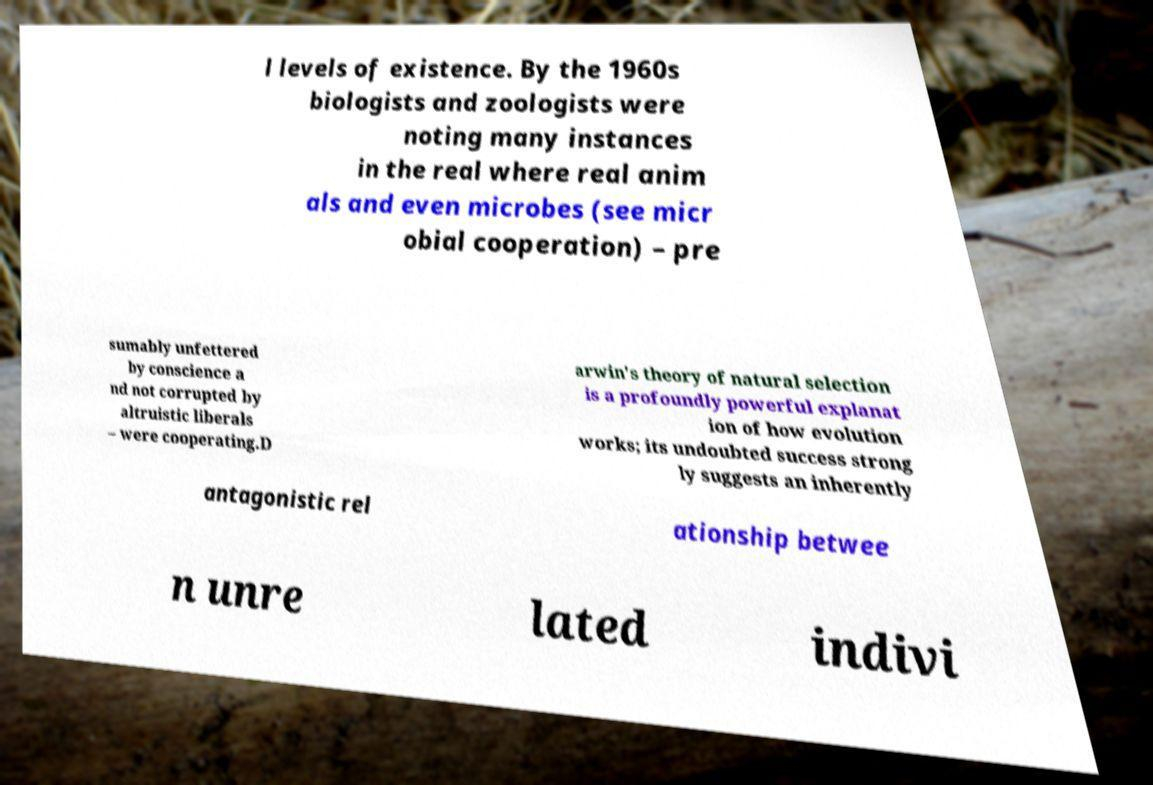There's text embedded in this image that I need extracted. Can you transcribe it verbatim? l levels of existence. By the 1960s biologists and zoologists were noting many instances in the real where real anim als and even microbes (see micr obial cooperation) – pre sumably unfettered by conscience a nd not corrupted by altruistic liberals – were cooperating.D arwin's theory of natural selection is a profoundly powerful explanat ion of how evolution works; its undoubted success strong ly suggests an inherently antagonistic rel ationship betwee n unre lated indivi 